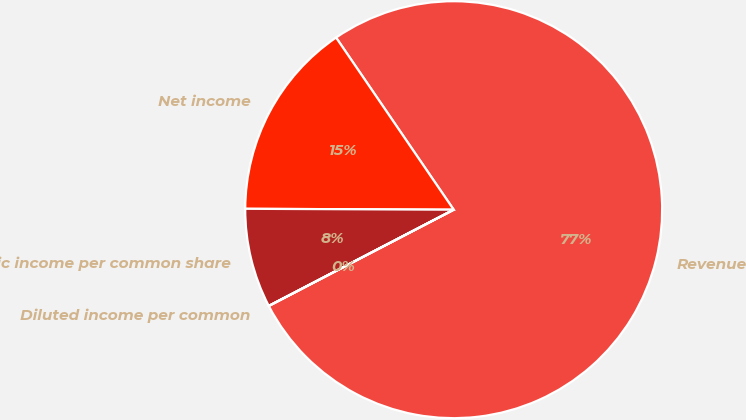<chart> <loc_0><loc_0><loc_500><loc_500><pie_chart><fcel>Revenue<fcel>Net income<fcel>Basic income per common share<fcel>Diluted income per common<nl><fcel>76.9%<fcel>15.39%<fcel>7.7%<fcel>0.01%<nl></chart> 